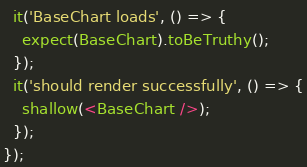<code> <loc_0><loc_0><loc_500><loc_500><_JavaScript_>  it('BaseChart loads', () => {
    expect(BaseChart).toBeTruthy();
  });
  it('should render successfully', () => {
    shallow(<BaseChart />);
  });
});
</code> 